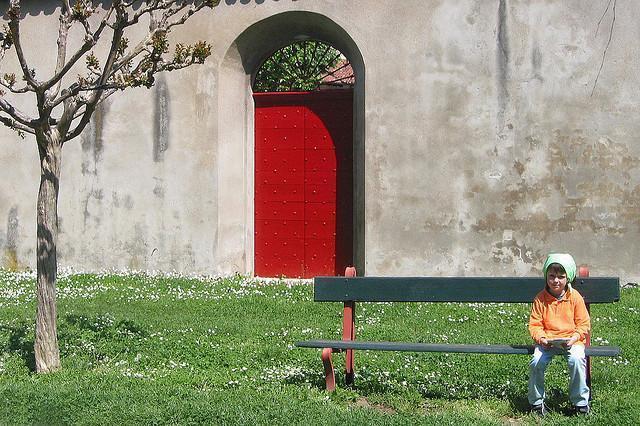How many oven handles do you see?
Give a very brief answer. 0. 